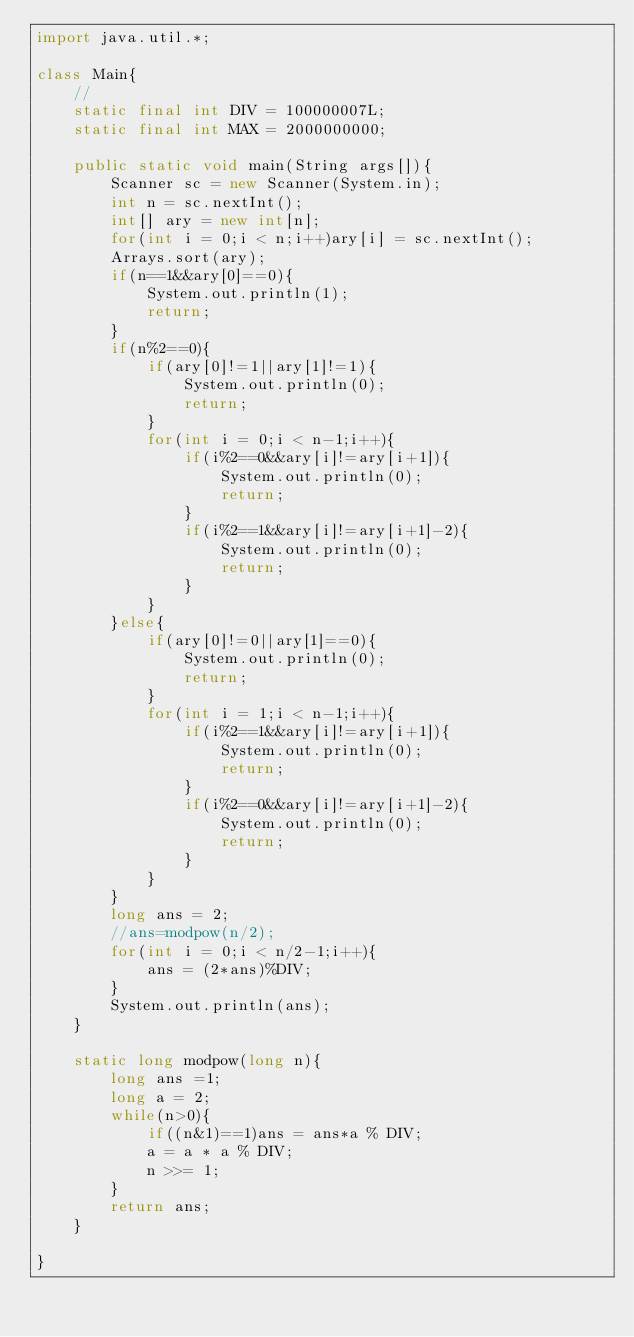Convert code to text. <code><loc_0><loc_0><loc_500><loc_500><_Java_>import java.util.*;

class Main{
    //
    static final int DIV = 100000007L;
    static final int MAX = 2000000000;
    
    public static void main(String args[]){
        Scanner sc = new Scanner(System.in);
        int n = sc.nextInt();
        int[] ary = new int[n];
        for(int i = 0;i < n;i++)ary[i] = sc.nextInt();
        Arrays.sort(ary);
        if(n==1&&ary[0]==0){
            System.out.println(1);
            return;
        }
        if(n%2==0){
            if(ary[0]!=1||ary[1]!=1){
                System.out.println(0);
                return;
            }
            for(int i = 0;i < n-1;i++){
                if(i%2==0&&ary[i]!=ary[i+1]){
                    System.out.println(0);
                    return;
                }
                if(i%2==1&&ary[i]!=ary[i+1]-2){
                    System.out.println(0);
                    return;
                }
            }
        }else{
            if(ary[0]!=0||ary[1]==0){
                System.out.println(0);
                return;
            }
            for(int i = 1;i < n-1;i++){
                if(i%2==1&&ary[i]!=ary[i+1]){
                    System.out.println(0);
                    return;
                }
                if(i%2==0&&ary[i]!=ary[i+1]-2){
                    System.out.println(0);
                    return;
                }
            }
        }
        long ans = 2;
        //ans=modpow(n/2);
        for(int i = 0;i < n/2-1;i++){
            ans = (2*ans)%DIV;
        }
        System.out.println(ans);
    }

    static long modpow(long n){
        long ans =1;
        long a = 2;
        while(n>0){
            if((n&1)==1)ans = ans*a % DIV;
            a = a * a % DIV;
            n >>= 1;
        }
        return ans;
    }
    
}</code> 